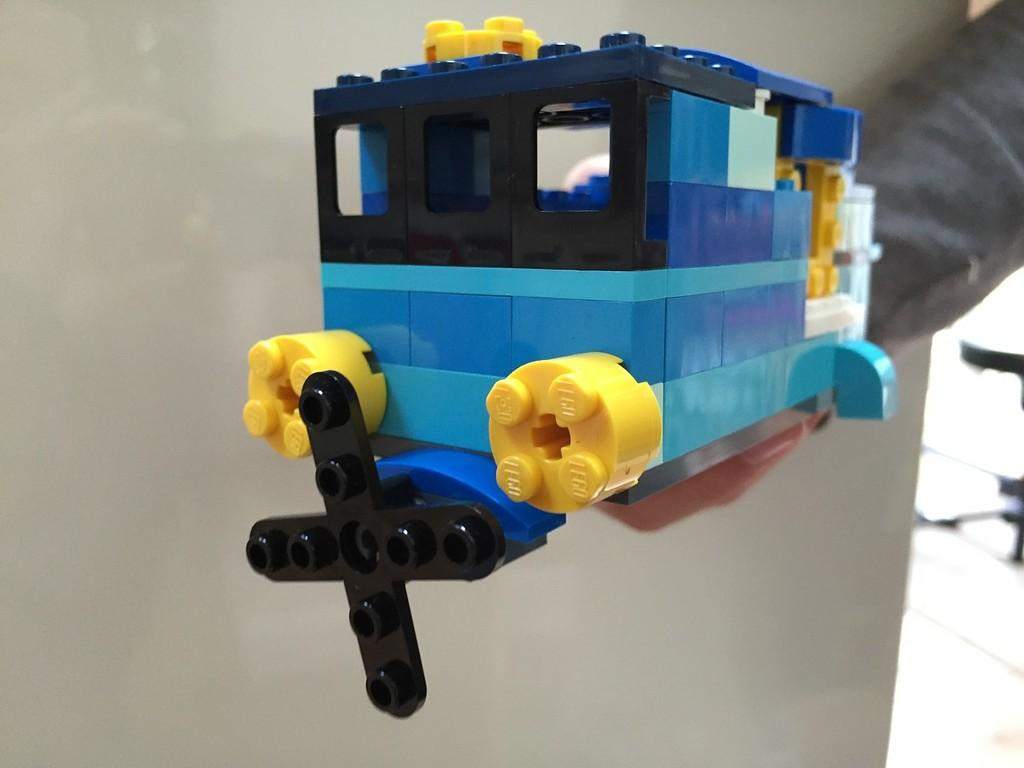What is the main subject of the image? There is a person in the image. What is the person holding in the image? The person's hand is holding a toy. What can be seen in the background of the image? There is a wall in the background of the image. Can you see any roses in the image? There are no roses present in the image. Where is the school located in the image? There is no school present in the image. 